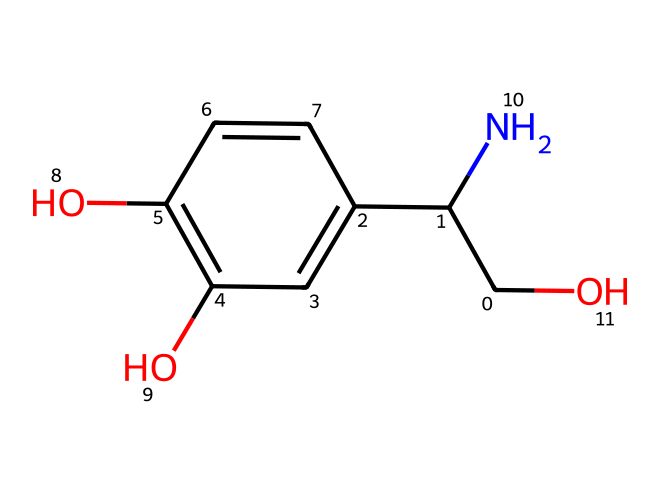What is the total number of carbon atoms in norepinephrine? Counting the carbon (C) atoms in the SMILES representation indicates there are five carbon atoms in the ring structure and three in the side chains, giving a total of eight carbon atoms.
Answer: eight How many hydroxyl (-OH) groups are present in this structure? By analyzing the SMILES, there are two instances of "-O" connected to hydrogen atoms, indicating two hydroxyl groups (the -OH groups) in the chemical structure.
Answer: two What type of functional groups are present in norepinephrine? The SMILES shows two hydroxyl groups (-OH) and an amine group (-NH) connected to a carbon atom. These functional groups are characteristic of phenolic compounds, particularly with an amine.
Answer: phenol and amine Which part of this chemical is responsible for its classification as a phenol? The presence of the benzene ring with hydroxyl substituents makes it a phenol. The attachment of -OH directly to the aromatic carbon classifies it under phenolic compounds.
Answer: benzene ring with hydroxyl Does norepinephrine have any double bonds? No double bonds are visually represented in the SMILES structure as there are only single bonds between carbon and other atoms, showing a saturated structure without any double bond connections.
Answer: no How many nitrogen atoms are in norepinephrine? The SMILES contains one 'N,' which denotes a single nitrogen atom in the molecular structure of norepinephrine.
Answer: one What is the overall molecular formula based on the representation? By counting the atoms from the SMILES, we find it has the elements: 8 carbons, 11 hydrogens, 3 oxygens, and 1 nitrogen, leading to the formula C8H11NO3.
Answer: C8H11NO3 